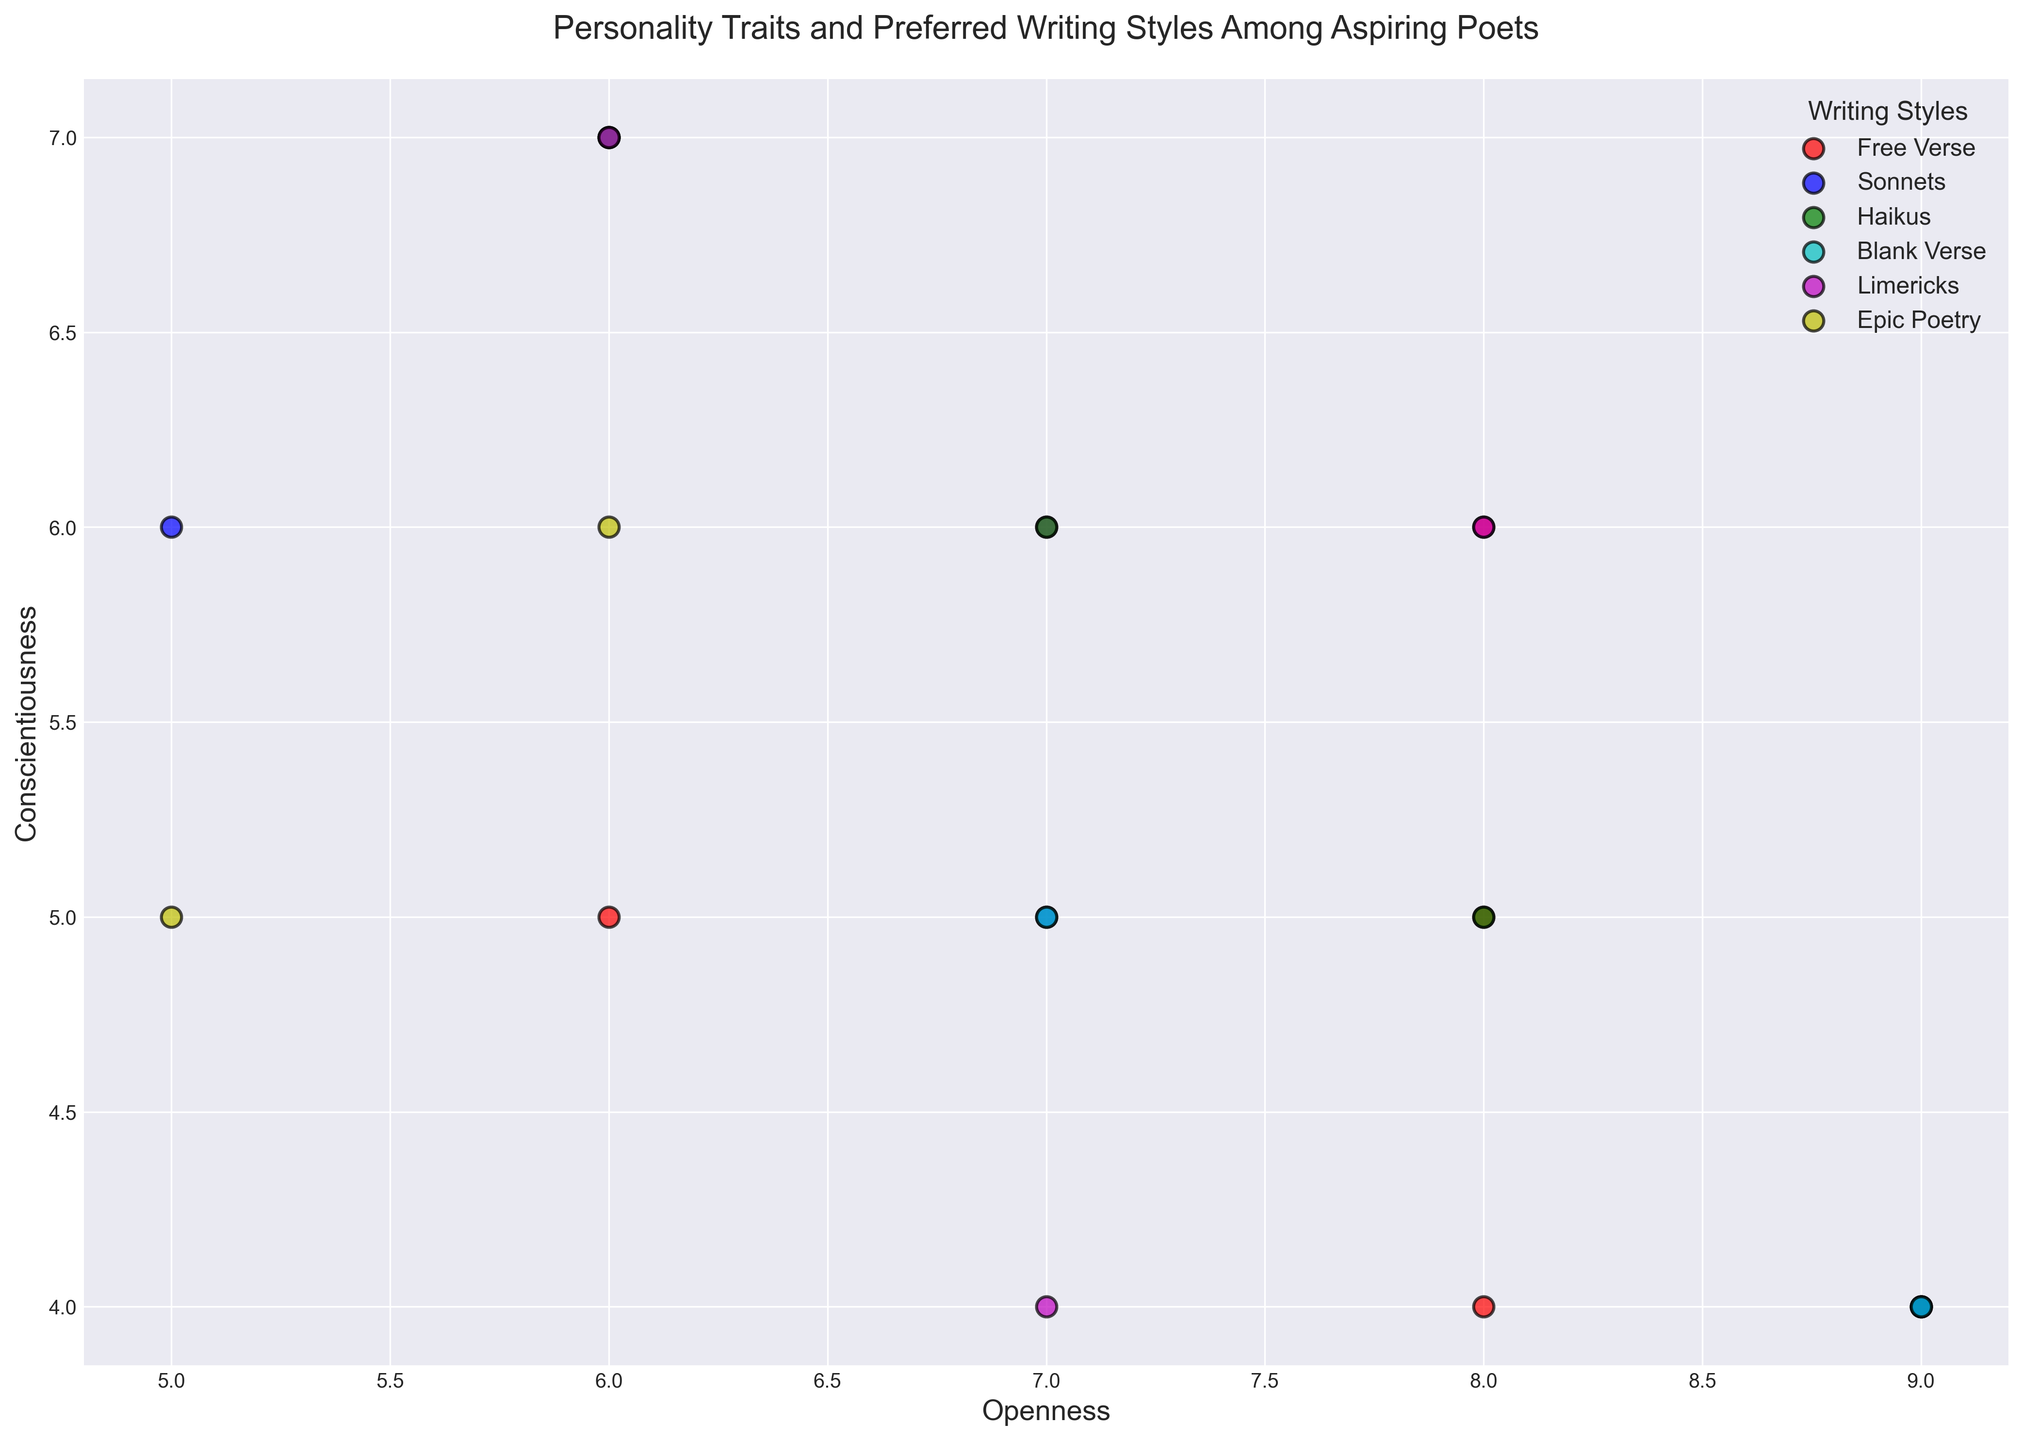What's the most common writing style represented on the chart? The legend shows that 'Free Verse' has the most data points (red dots) scattered across the plot. By visually inspecting the number of red dots compared to other colors, it's clear that 'Free Verse' is the most common.
Answer: Free Verse Which writing style has the highest Openness on average? To determine this, locate each dot corresponding to a writing style and note their positions on the Openness axis. Average the Openness values for all points of each writing style. 'Haikus' have generally higher values ranging around Openness 8 and 9.
Answer: Haikus Compare the average Conscientiousness of 'Sonnets' and 'Blank Verse'. Which one is higher? Find the markers for 'Sonnets' (blue dots) and 'Blank Verse' (cyan dots). Calculate the average Conscientiousness values for each group. Most 'Sonnets' fall around Conscientiousness 5, while 'Blank Verse' dots are mainly around 6-7.
Answer: Blank Verse Is there a writing style predominantly associated with high Neuroticism? Observe the dots of each writing style and note the Neuroticism values. 'Haikus' typically have higher Neuroticism values as they cluster more to the right on the Neuroticism axis.
Answer: Haikus Identify any outliers on the plot. What writing styles do they belong to? Visually scan for any markers significantly distant from others. There's a 'Haikus' point (green dot) with high Openness and high Neuroticism, and another 'Epic Poetry' (yellow dot) with average personality traits, standing alone.
Answer: Haikus, Epic Poetry Which writing style has the highest variance in Conscientiousness? By examining the spread of the points, 'Blank Verse' (cyan dots) shows a wider range of Conscientiousness values, indicating higher variance.
Answer: Blank Verse What's the average Agreeableness for poets preferring 'Free Verse'? Locate red dots representing 'Free Verse' and sum their Agreeableness values: (7+7+9+5) and divide by the number of dots.
Answer: 7 Between 'Limericks' and 'Haikus' poets, who are generally more open? Compare the positions of magenta dots (Limericks) and green dots (Haikus) on the Openness axis. 'Haikus' consistently show higher Openness scores.
Answer: Haikus 